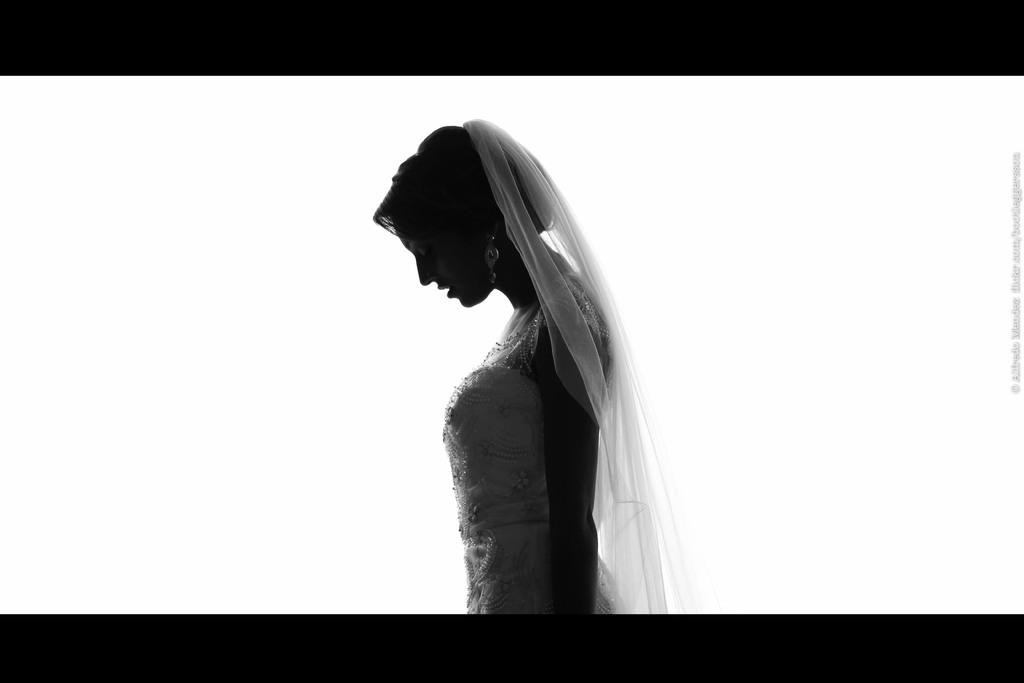Who is the main subject in the image? There is a bride in the image. What can be seen on the right side of the image? There is a watermark on the right side of the image. What color is the background of the image? The background of the image is white. What color scheme is used in the image? The image is in black and white. How many friends are visible in the image? There is no mention of friends in the image, as it primarily features the bride. What type of wax is used to create the bride's makeup in the image? There is no information about the bride's makeup in the image, and therefore no details about the type of wax used. 